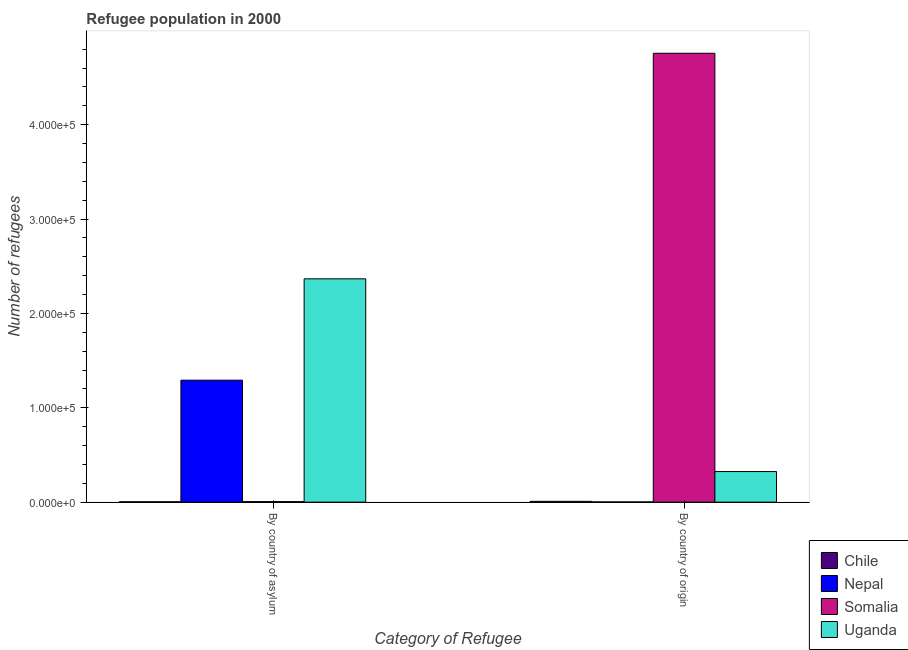How many different coloured bars are there?
Make the answer very short. 4. How many bars are there on the 2nd tick from the left?
Provide a short and direct response. 4. What is the label of the 2nd group of bars from the left?
Your response must be concise. By country of origin. What is the number of refugees by country of asylum in Uganda?
Your answer should be very brief. 2.37e+05. Across all countries, what is the maximum number of refugees by country of origin?
Your answer should be very brief. 4.76e+05. Across all countries, what is the minimum number of refugees by country of origin?
Your response must be concise. 235. In which country was the number of refugees by country of asylum maximum?
Your response must be concise. Uganda. In which country was the number of refugees by country of origin minimum?
Give a very brief answer. Nepal. What is the total number of refugees by country of asylum in the graph?
Make the answer very short. 3.67e+05. What is the difference between the number of refugees by country of origin in Uganda and that in Nepal?
Your response must be concise. 3.22e+04. What is the difference between the number of refugees by country of asylum in Uganda and the number of refugees by country of origin in Chile?
Ensure brevity in your answer.  2.36e+05. What is the average number of refugees by country of asylum per country?
Your answer should be very brief. 9.17e+04. What is the difference between the number of refugees by country of origin and number of refugees by country of asylum in Somalia?
Provide a short and direct response. 4.75e+05. In how many countries, is the number of refugees by country of origin greater than 60000 ?
Make the answer very short. 1. What is the ratio of the number of refugees by country of origin in Uganda to that in Chile?
Offer a terse response. 37.69. Is the number of refugees by country of origin in Uganda less than that in Somalia?
Provide a short and direct response. Yes. In how many countries, is the number of refugees by country of origin greater than the average number of refugees by country of origin taken over all countries?
Provide a succinct answer. 1. What does the 2nd bar from the left in By country of origin represents?
Give a very brief answer. Nepal. What does the 3rd bar from the right in By country of origin represents?
Offer a terse response. Nepal. How many countries are there in the graph?
Ensure brevity in your answer.  4. What is the difference between two consecutive major ticks on the Y-axis?
Your response must be concise. 1.00e+05. Does the graph contain any zero values?
Give a very brief answer. No. What is the title of the graph?
Ensure brevity in your answer.  Refugee population in 2000. What is the label or title of the X-axis?
Make the answer very short. Category of Refugee. What is the label or title of the Y-axis?
Provide a short and direct response. Number of refugees. What is the Number of refugees in Chile in By country of asylum?
Provide a succinct answer. 364. What is the Number of refugees in Nepal in By country of asylum?
Make the answer very short. 1.29e+05. What is the Number of refugees of Somalia in By country of asylum?
Provide a succinct answer. 558. What is the Number of refugees of Uganda in By country of asylum?
Your response must be concise. 2.37e+05. What is the Number of refugees in Chile in By country of origin?
Ensure brevity in your answer.  860. What is the Number of refugees of Nepal in By country of origin?
Give a very brief answer. 235. What is the Number of refugees of Somalia in By country of origin?
Your response must be concise. 4.76e+05. What is the Number of refugees in Uganda in By country of origin?
Offer a terse response. 3.24e+04. Across all Category of Refugee, what is the maximum Number of refugees of Chile?
Ensure brevity in your answer.  860. Across all Category of Refugee, what is the maximum Number of refugees of Nepal?
Keep it short and to the point. 1.29e+05. Across all Category of Refugee, what is the maximum Number of refugees of Somalia?
Offer a very short reply. 4.76e+05. Across all Category of Refugee, what is the maximum Number of refugees of Uganda?
Your response must be concise. 2.37e+05. Across all Category of Refugee, what is the minimum Number of refugees of Chile?
Ensure brevity in your answer.  364. Across all Category of Refugee, what is the minimum Number of refugees of Nepal?
Your answer should be very brief. 235. Across all Category of Refugee, what is the minimum Number of refugees of Somalia?
Make the answer very short. 558. Across all Category of Refugee, what is the minimum Number of refugees of Uganda?
Offer a very short reply. 3.24e+04. What is the total Number of refugees in Chile in the graph?
Your answer should be compact. 1224. What is the total Number of refugees in Nepal in the graph?
Make the answer very short. 1.29e+05. What is the total Number of refugees of Somalia in the graph?
Your answer should be very brief. 4.76e+05. What is the total Number of refugees of Uganda in the graph?
Your answer should be very brief. 2.69e+05. What is the difference between the Number of refugees of Chile in By country of asylum and that in By country of origin?
Ensure brevity in your answer.  -496. What is the difference between the Number of refugees in Nepal in By country of asylum and that in By country of origin?
Offer a very short reply. 1.29e+05. What is the difference between the Number of refugees of Somalia in By country of asylum and that in By country of origin?
Your answer should be very brief. -4.75e+05. What is the difference between the Number of refugees of Uganda in By country of asylum and that in By country of origin?
Make the answer very short. 2.04e+05. What is the difference between the Number of refugees of Chile in By country of asylum and the Number of refugees of Nepal in By country of origin?
Offer a terse response. 129. What is the difference between the Number of refugees in Chile in By country of asylum and the Number of refugees in Somalia in By country of origin?
Offer a very short reply. -4.75e+05. What is the difference between the Number of refugees of Chile in By country of asylum and the Number of refugees of Uganda in By country of origin?
Make the answer very short. -3.20e+04. What is the difference between the Number of refugees of Nepal in By country of asylum and the Number of refugees of Somalia in By country of origin?
Ensure brevity in your answer.  -3.46e+05. What is the difference between the Number of refugees of Nepal in By country of asylum and the Number of refugees of Uganda in By country of origin?
Ensure brevity in your answer.  9.68e+04. What is the difference between the Number of refugees of Somalia in By country of asylum and the Number of refugees of Uganda in By country of origin?
Your response must be concise. -3.19e+04. What is the average Number of refugees of Chile per Category of Refugee?
Provide a succinct answer. 612. What is the average Number of refugees of Nepal per Category of Refugee?
Provide a succinct answer. 6.47e+04. What is the average Number of refugees in Somalia per Category of Refugee?
Provide a short and direct response. 2.38e+05. What is the average Number of refugees in Uganda per Category of Refugee?
Your answer should be very brief. 1.35e+05. What is the difference between the Number of refugees in Chile and Number of refugees in Nepal in By country of asylum?
Your response must be concise. -1.29e+05. What is the difference between the Number of refugees in Chile and Number of refugees in Somalia in By country of asylum?
Offer a very short reply. -194. What is the difference between the Number of refugees of Chile and Number of refugees of Uganda in By country of asylum?
Offer a very short reply. -2.36e+05. What is the difference between the Number of refugees in Nepal and Number of refugees in Somalia in By country of asylum?
Give a very brief answer. 1.29e+05. What is the difference between the Number of refugees of Nepal and Number of refugees of Uganda in By country of asylum?
Ensure brevity in your answer.  -1.07e+05. What is the difference between the Number of refugees in Somalia and Number of refugees in Uganda in By country of asylum?
Offer a terse response. -2.36e+05. What is the difference between the Number of refugees in Chile and Number of refugees in Nepal in By country of origin?
Your answer should be very brief. 625. What is the difference between the Number of refugees in Chile and Number of refugees in Somalia in By country of origin?
Provide a short and direct response. -4.75e+05. What is the difference between the Number of refugees in Chile and Number of refugees in Uganda in By country of origin?
Ensure brevity in your answer.  -3.16e+04. What is the difference between the Number of refugees of Nepal and Number of refugees of Somalia in By country of origin?
Offer a terse response. -4.75e+05. What is the difference between the Number of refugees in Nepal and Number of refugees in Uganda in By country of origin?
Offer a terse response. -3.22e+04. What is the difference between the Number of refugees of Somalia and Number of refugees of Uganda in By country of origin?
Ensure brevity in your answer.  4.43e+05. What is the ratio of the Number of refugees of Chile in By country of asylum to that in By country of origin?
Provide a short and direct response. 0.42. What is the ratio of the Number of refugees in Nepal in By country of asylum to that in By country of origin?
Your response must be concise. 549.94. What is the ratio of the Number of refugees of Somalia in By country of asylum to that in By country of origin?
Provide a short and direct response. 0. What is the difference between the highest and the second highest Number of refugees in Chile?
Provide a short and direct response. 496. What is the difference between the highest and the second highest Number of refugees of Nepal?
Make the answer very short. 1.29e+05. What is the difference between the highest and the second highest Number of refugees in Somalia?
Make the answer very short. 4.75e+05. What is the difference between the highest and the second highest Number of refugees of Uganda?
Offer a terse response. 2.04e+05. What is the difference between the highest and the lowest Number of refugees of Chile?
Give a very brief answer. 496. What is the difference between the highest and the lowest Number of refugees of Nepal?
Offer a very short reply. 1.29e+05. What is the difference between the highest and the lowest Number of refugees of Somalia?
Make the answer very short. 4.75e+05. What is the difference between the highest and the lowest Number of refugees in Uganda?
Your answer should be compact. 2.04e+05. 